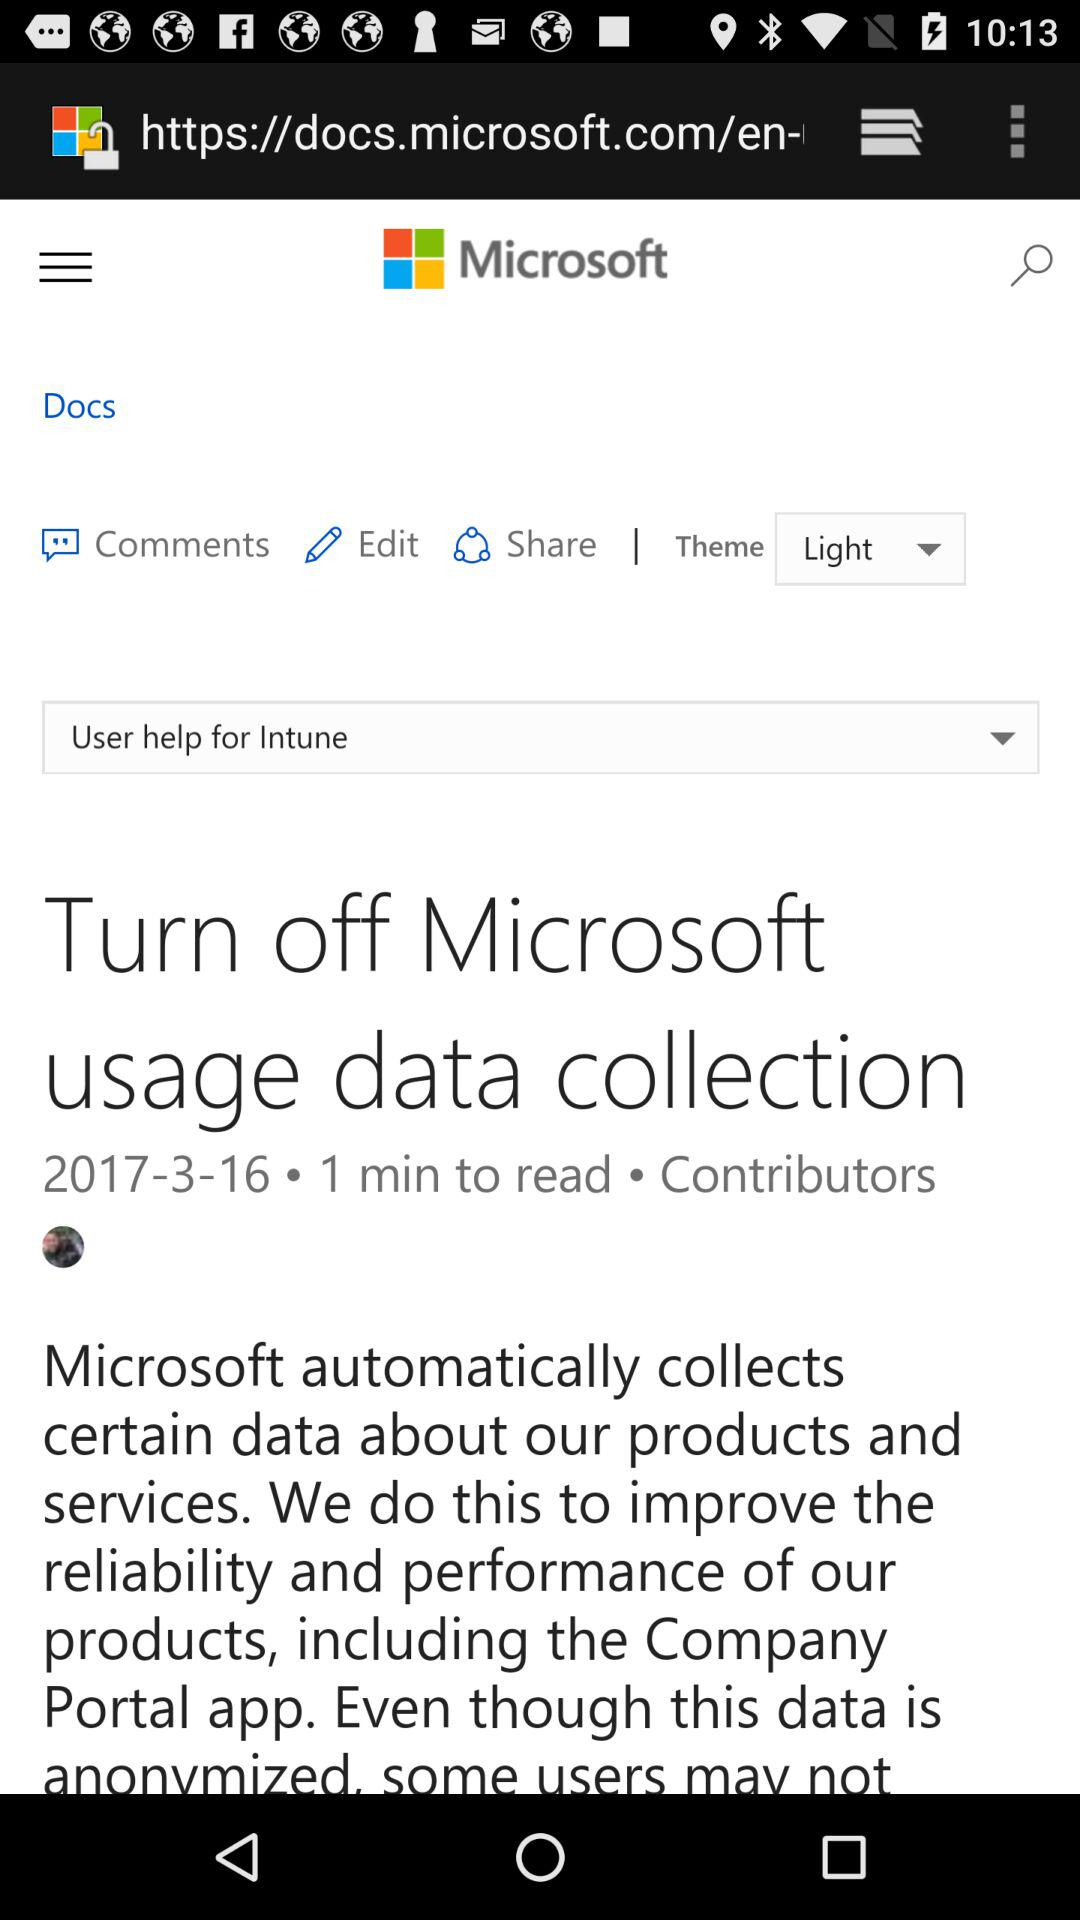What is the selected theme? The selected theme is "Light". 